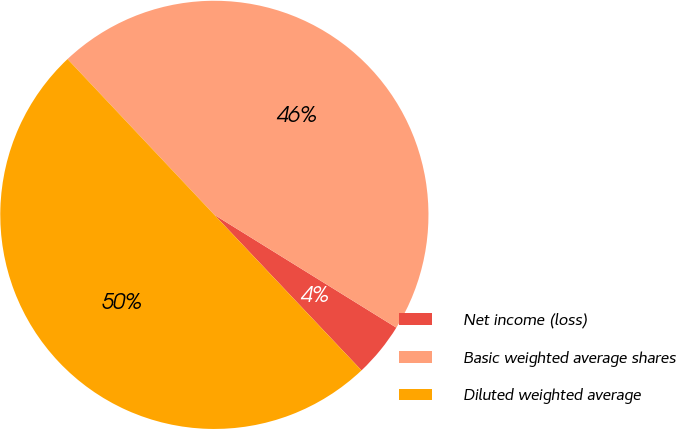Convert chart. <chart><loc_0><loc_0><loc_500><loc_500><pie_chart><fcel>Net income (loss)<fcel>Basic weighted average shares<fcel>Diluted weighted average<nl><fcel>4.11%<fcel>45.86%<fcel>50.03%<nl></chart> 